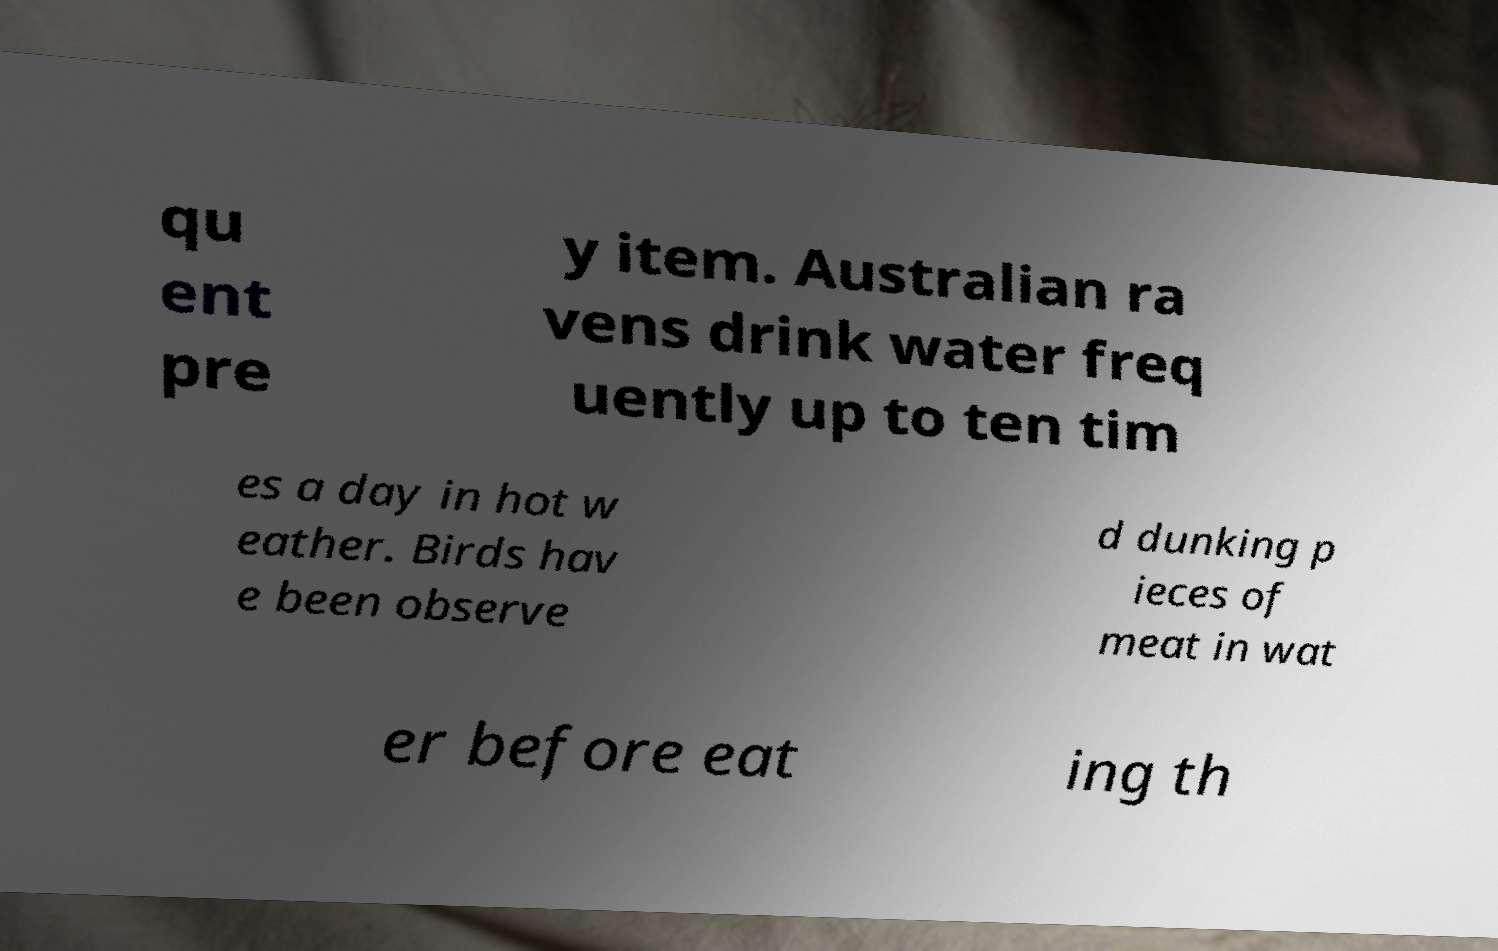For documentation purposes, I need the text within this image transcribed. Could you provide that? qu ent pre y item. Australian ra vens drink water freq uently up to ten tim es a day in hot w eather. Birds hav e been observe d dunking p ieces of meat in wat er before eat ing th 